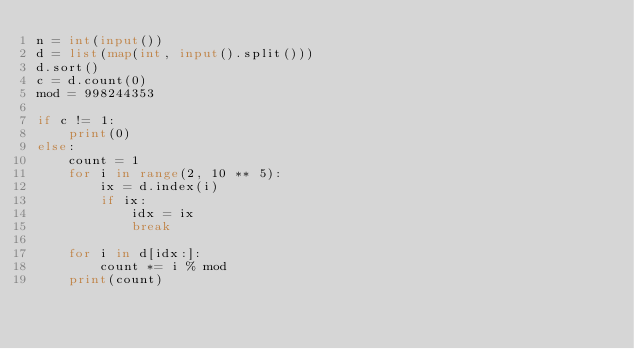Convert code to text. <code><loc_0><loc_0><loc_500><loc_500><_Python_>n = int(input())
d = list(map(int, input().split()))
d.sort()
c = d.count(0)
mod = 998244353

if c != 1:
    print(0)
else:
    count = 1
    for i in range(2, 10 ** 5):
        ix = d.index(i)
        if ix:
            idx = ix
            break

    for i in d[idx:]:
        count *= i % mod
    print(count)
</code> 